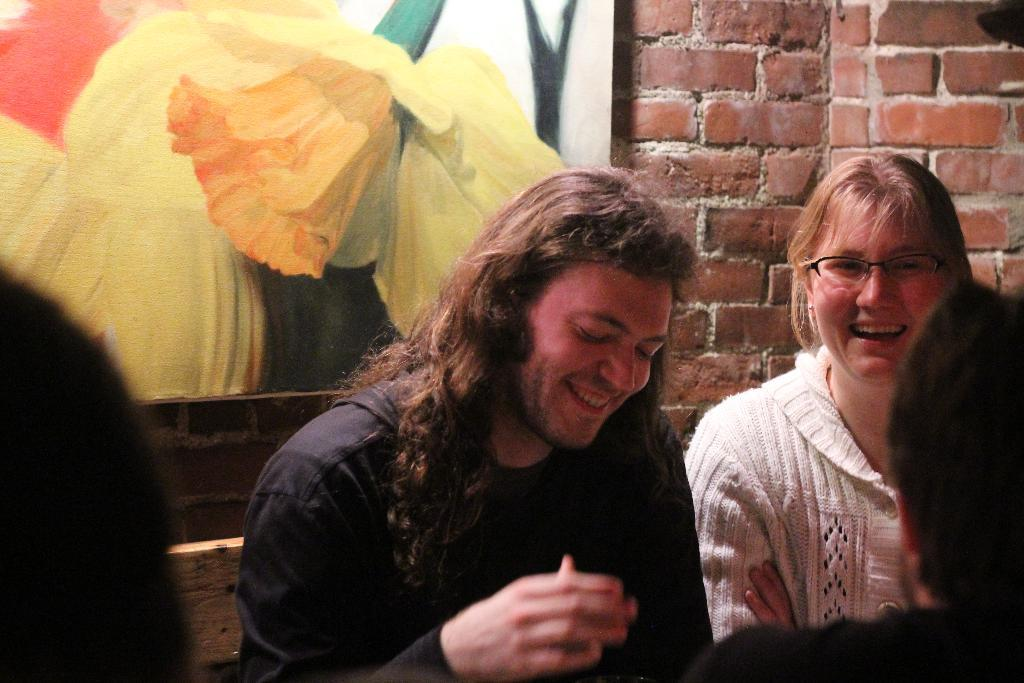What is located in the foreground of the image? There are heads of a person in the foreground of the image. What can be seen in the middle of the image? There is a man and a woman in the middle of the image. What is the facial expression of the man and woman? The man and woman are smiling. What is visible in the background of the image? There is a frame in the background of the image. What is the frame attached to? The frame is on a brick wall. What type of mint is growing on the brick wall in the image? There is no mint present in the image; it features a frame on a brick wall. How many beds can be seen in the image? There are no beds visible in the image. 